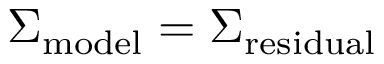<formula> <loc_0><loc_0><loc_500><loc_500>\Sigma _ { m o d e l } = \Sigma _ { r e s i d u a l }</formula> 